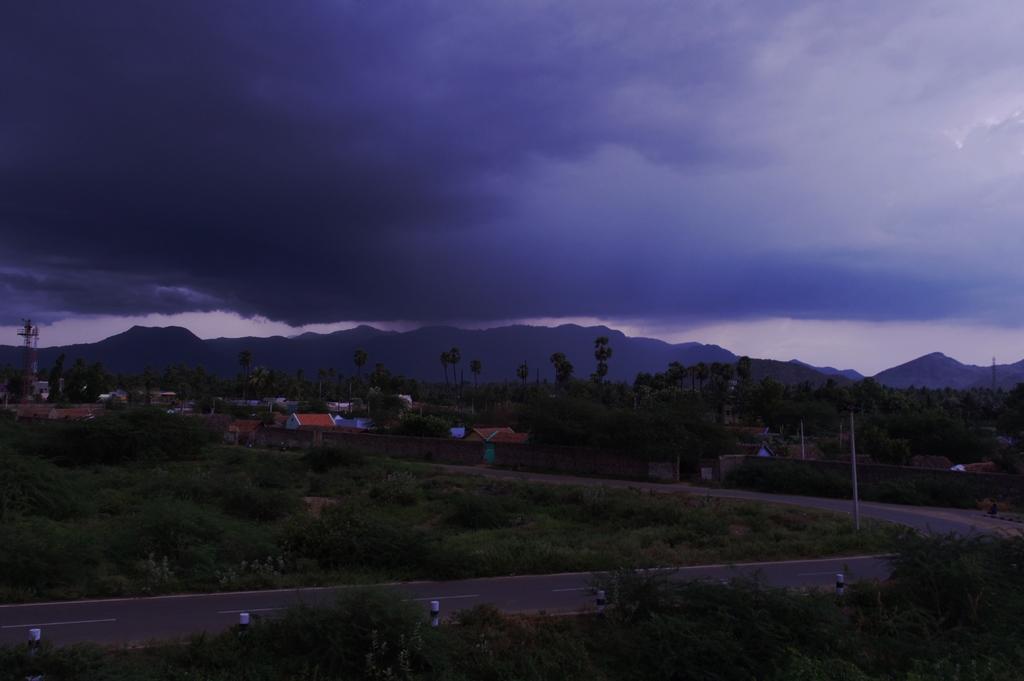Could you give a brief overview of what you see in this image? In the center of the image there is road. there are plants. In the background of the image there are mountains, trees, houses. At the top of the image there are clouds and sky. 